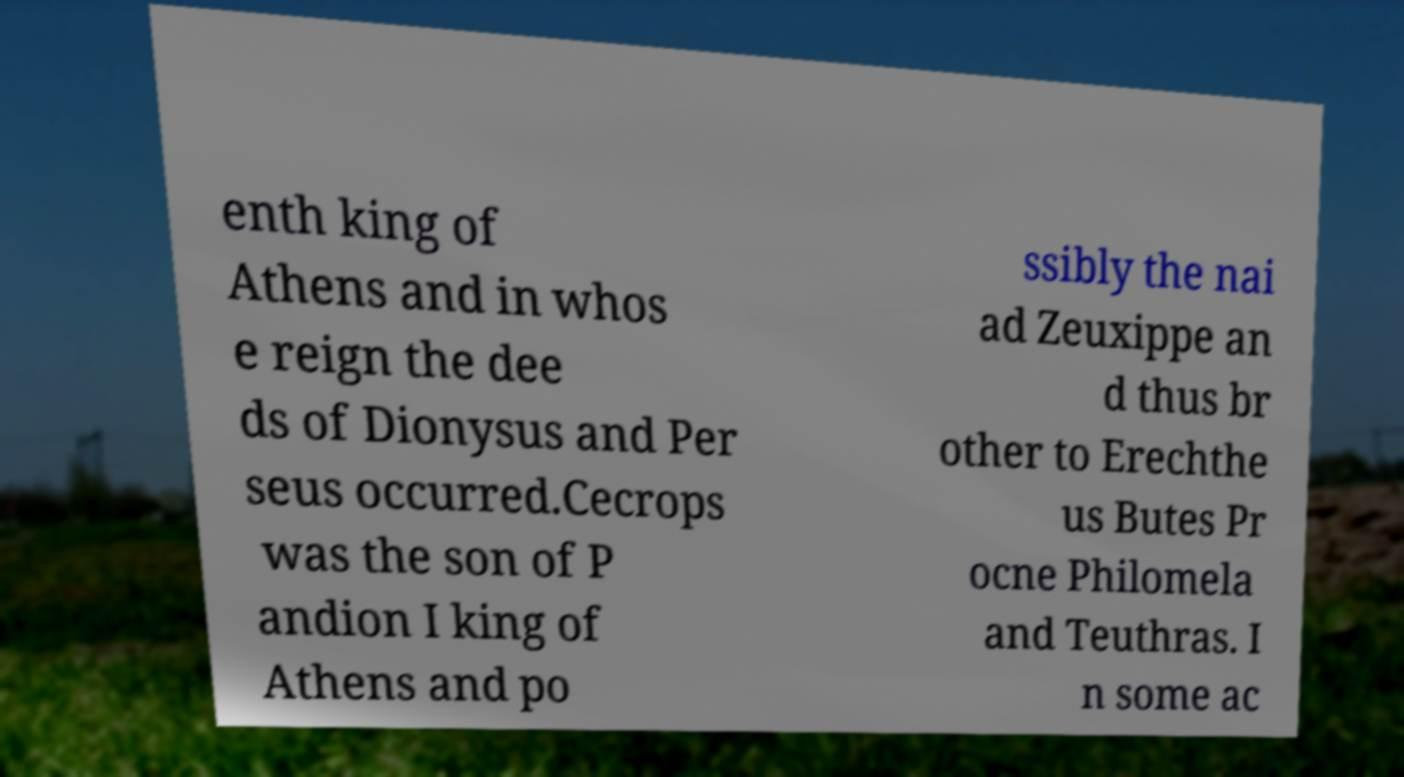Please identify and transcribe the text found in this image. enth king of Athens and in whos e reign the dee ds of Dionysus and Per seus occurred.Cecrops was the son of P andion I king of Athens and po ssibly the nai ad Zeuxippe an d thus br other to Erechthe us Butes Pr ocne Philomela and Teuthras. I n some ac 